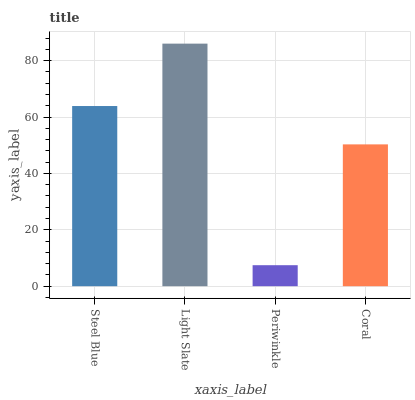Is Periwinkle the minimum?
Answer yes or no. Yes. Is Light Slate the maximum?
Answer yes or no. Yes. Is Light Slate the minimum?
Answer yes or no. No. Is Periwinkle the maximum?
Answer yes or no. No. Is Light Slate greater than Periwinkle?
Answer yes or no. Yes. Is Periwinkle less than Light Slate?
Answer yes or no. Yes. Is Periwinkle greater than Light Slate?
Answer yes or no. No. Is Light Slate less than Periwinkle?
Answer yes or no. No. Is Steel Blue the high median?
Answer yes or no. Yes. Is Coral the low median?
Answer yes or no. Yes. Is Periwinkle the high median?
Answer yes or no. No. Is Light Slate the low median?
Answer yes or no. No. 